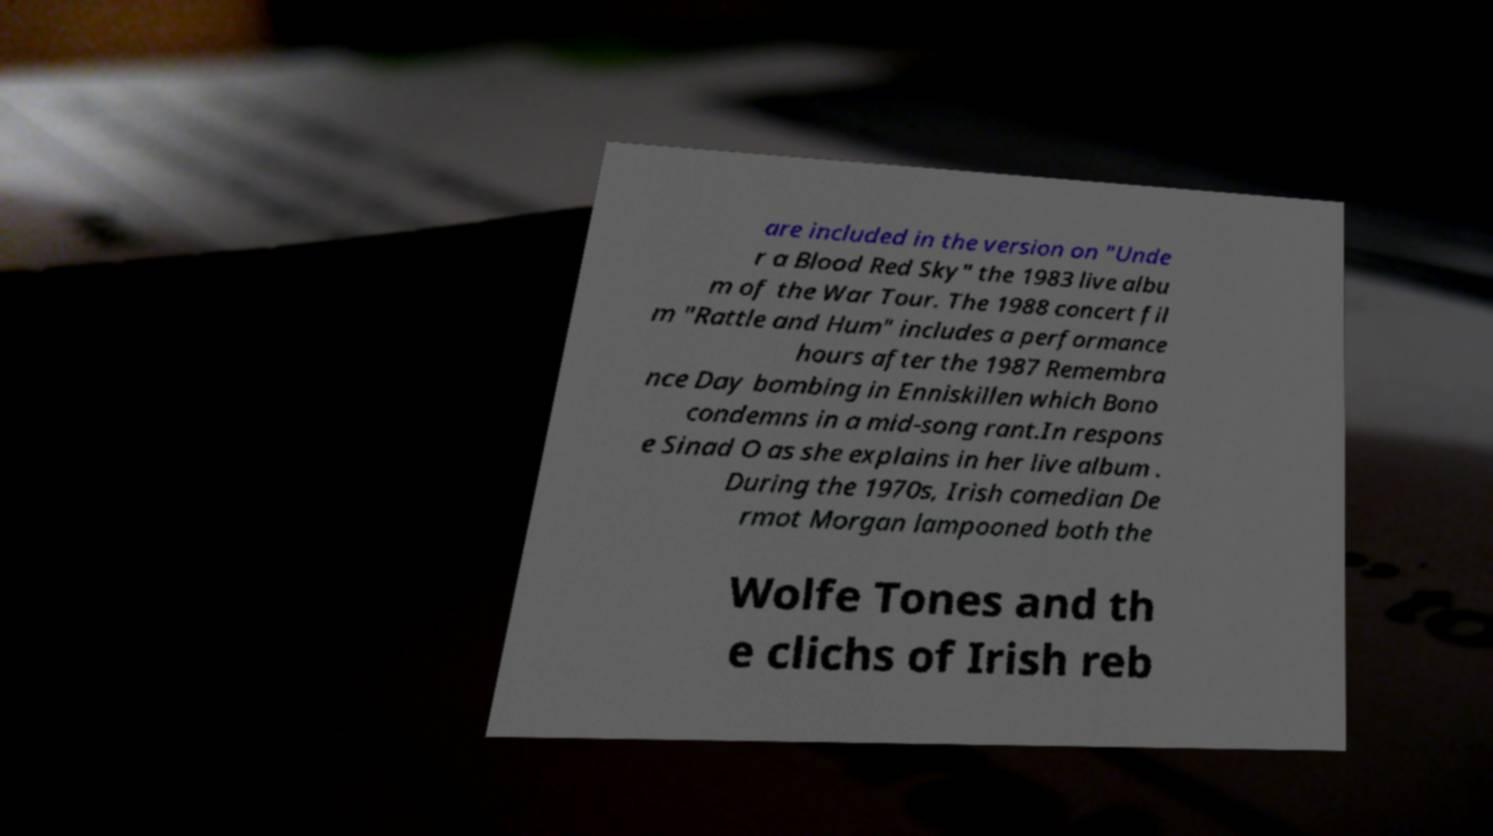For documentation purposes, I need the text within this image transcribed. Could you provide that? are included in the version on "Unde r a Blood Red Sky" the 1983 live albu m of the War Tour. The 1988 concert fil m "Rattle and Hum" includes a performance hours after the 1987 Remembra nce Day bombing in Enniskillen which Bono condemns in a mid-song rant.In respons e Sinad O as she explains in her live album . During the 1970s, Irish comedian De rmot Morgan lampooned both the Wolfe Tones and th e clichs of Irish reb 